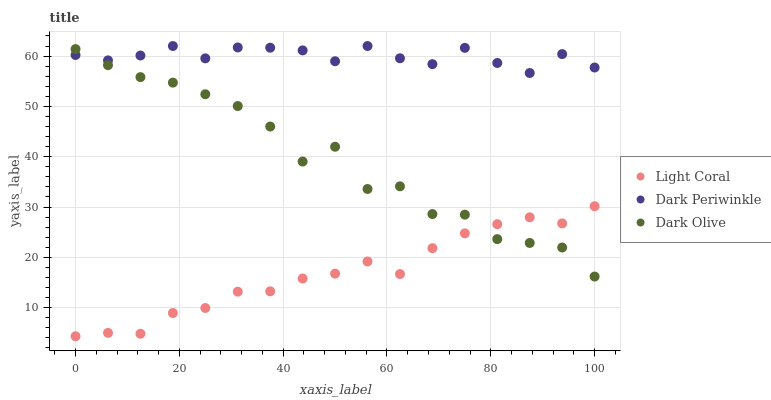Does Light Coral have the minimum area under the curve?
Answer yes or no. Yes. Does Dark Periwinkle have the maximum area under the curve?
Answer yes or no. Yes. Does Dark Olive have the minimum area under the curve?
Answer yes or no. No. Does Dark Olive have the maximum area under the curve?
Answer yes or no. No. Is Light Coral the smoothest?
Answer yes or no. Yes. Is Dark Olive the roughest?
Answer yes or no. Yes. Is Dark Periwinkle the smoothest?
Answer yes or no. No. Is Dark Periwinkle the roughest?
Answer yes or no. No. Does Light Coral have the lowest value?
Answer yes or no. Yes. Does Dark Olive have the lowest value?
Answer yes or no. No. Does Dark Periwinkle have the highest value?
Answer yes or no. Yes. Does Dark Olive have the highest value?
Answer yes or no. No. Is Light Coral less than Dark Periwinkle?
Answer yes or no. Yes. Is Dark Periwinkle greater than Light Coral?
Answer yes or no. Yes. Does Light Coral intersect Dark Olive?
Answer yes or no. Yes. Is Light Coral less than Dark Olive?
Answer yes or no. No. Is Light Coral greater than Dark Olive?
Answer yes or no. No. Does Light Coral intersect Dark Periwinkle?
Answer yes or no. No. 